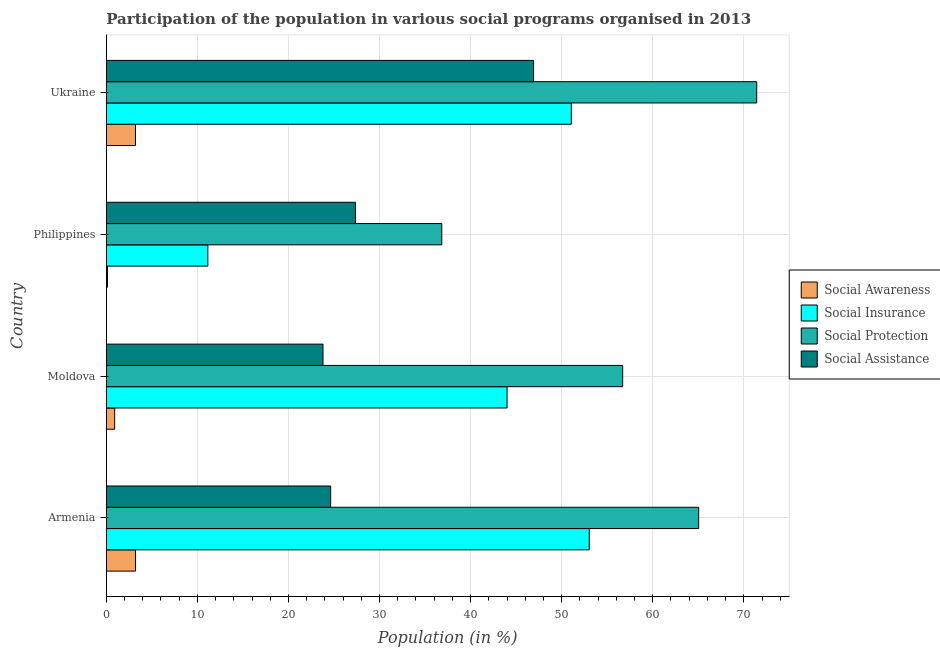How many different coloured bars are there?
Give a very brief answer. 4. Are the number of bars on each tick of the Y-axis equal?
Keep it short and to the point. Yes. How many bars are there on the 2nd tick from the bottom?
Offer a very short reply. 4. What is the label of the 3rd group of bars from the top?
Give a very brief answer. Moldova. In how many cases, is the number of bars for a given country not equal to the number of legend labels?
Your answer should be compact. 0. What is the participation of population in social insurance programs in Ukraine?
Make the answer very short. 51.06. Across all countries, what is the maximum participation of population in social awareness programs?
Make the answer very short. 3.21. Across all countries, what is the minimum participation of population in social assistance programs?
Offer a very short reply. 23.79. In which country was the participation of population in social insurance programs maximum?
Your answer should be compact. Armenia. In which country was the participation of population in social assistance programs minimum?
Ensure brevity in your answer.  Moldova. What is the total participation of population in social assistance programs in the graph?
Your answer should be very brief. 122.7. What is the difference between the participation of population in social insurance programs in Moldova and that in Ukraine?
Your answer should be compact. -7.05. What is the difference between the participation of population in social protection programs in Philippines and the participation of population in social awareness programs in Armenia?
Ensure brevity in your answer.  33.63. What is the average participation of population in social assistance programs per country?
Provide a succinct answer. 30.67. What is the difference between the participation of population in social protection programs and participation of population in social insurance programs in Armenia?
Ensure brevity in your answer.  12.01. In how many countries, is the participation of population in social insurance programs greater than 12 %?
Offer a very short reply. 3. What is the ratio of the participation of population in social protection programs in Moldova to that in Ukraine?
Give a very brief answer. 0.79. Is the participation of population in social assistance programs in Moldova less than that in Philippines?
Make the answer very short. Yes. Is the difference between the participation of population in social insurance programs in Armenia and Philippines greater than the difference between the participation of population in social assistance programs in Armenia and Philippines?
Your answer should be compact. Yes. What is the difference between the highest and the second highest participation of population in social insurance programs?
Your answer should be compact. 1.97. What is the difference between the highest and the lowest participation of population in social insurance programs?
Provide a short and direct response. 41.88. Is the sum of the participation of population in social protection programs in Moldova and Philippines greater than the maximum participation of population in social assistance programs across all countries?
Make the answer very short. Yes. What does the 4th bar from the top in Ukraine represents?
Offer a very short reply. Social Awareness. What does the 2nd bar from the bottom in Ukraine represents?
Keep it short and to the point. Social Insurance. How many bars are there?
Offer a terse response. 16. How many countries are there in the graph?
Your answer should be very brief. 4. What is the difference between two consecutive major ticks on the X-axis?
Provide a succinct answer. 10. Does the graph contain grids?
Ensure brevity in your answer.  Yes. How many legend labels are there?
Give a very brief answer. 4. What is the title of the graph?
Offer a very short reply. Participation of the population in various social programs organised in 2013. What is the label or title of the X-axis?
Make the answer very short. Population (in %). What is the label or title of the Y-axis?
Your response must be concise. Country. What is the Population (in %) in Social Awareness in Armenia?
Provide a short and direct response. 3.21. What is the Population (in %) in Social Insurance in Armenia?
Provide a short and direct response. 53.03. What is the Population (in %) of Social Protection in Armenia?
Provide a short and direct response. 65.04. What is the Population (in %) in Social Assistance in Armenia?
Give a very brief answer. 24.63. What is the Population (in %) in Social Awareness in Moldova?
Provide a succinct answer. 0.92. What is the Population (in %) of Social Insurance in Moldova?
Provide a short and direct response. 44.01. What is the Population (in %) of Social Protection in Moldova?
Your response must be concise. 56.7. What is the Population (in %) of Social Assistance in Moldova?
Your answer should be very brief. 23.79. What is the Population (in %) in Social Awareness in Philippines?
Provide a succinct answer. 0.12. What is the Population (in %) of Social Insurance in Philippines?
Offer a terse response. 11.15. What is the Population (in %) in Social Protection in Philippines?
Your response must be concise. 36.84. What is the Population (in %) in Social Assistance in Philippines?
Give a very brief answer. 27.35. What is the Population (in %) of Social Awareness in Ukraine?
Your answer should be compact. 3.2. What is the Population (in %) of Social Insurance in Ukraine?
Offer a terse response. 51.06. What is the Population (in %) of Social Protection in Ukraine?
Give a very brief answer. 71.42. What is the Population (in %) of Social Assistance in Ukraine?
Provide a short and direct response. 46.92. Across all countries, what is the maximum Population (in %) of Social Awareness?
Your response must be concise. 3.21. Across all countries, what is the maximum Population (in %) of Social Insurance?
Offer a terse response. 53.03. Across all countries, what is the maximum Population (in %) in Social Protection?
Your response must be concise. 71.42. Across all countries, what is the maximum Population (in %) of Social Assistance?
Provide a succinct answer. 46.92. Across all countries, what is the minimum Population (in %) of Social Awareness?
Your answer should be compact. 0.12. Across all countries, what is the minimum Population (in %) of Social Insurance?
Your response must be concise. 11.15. Across all countries, what is the minimum Population (in %) of Social Protection?
Your answer should be compact. 36.84. Across all countries, what is the minimum Population (in %) in Social Assistance?
Your answer should be compact. 23.79. What is the total Population (in %) of Social Awareness in the graph?
Give a very brief answer. 7.45. What is the total Population (in %) of Social Insurance in the graph?
Give a very brief answer. 159.24. What is the total Population (in %) in Social Protection in the graph?
Your response must be concise. 230. What is the total Population (in %) in Social Assistance in the graph?
Offer a very short reply. 122.7. What is the difference between the Population (in %) in Social Awareness in Armenia and that in Moldova?
Ensure brevity in your answer.  2.29. What is the difference between the Population (in %) of Social Insurance in Armenia and that in Moldova?
Make the answer very short. 9.03. What is the difference between the Population (in %) in Social Protection in Armenia and that in Moldova?
Offer a terse response. 8.34. What is the difference between the Population (in %) of Social Assistance in Armenia and that in Moldova?
Offer a very short reply. 0.84. What is the difference between the Population (in %) of Social Awareness in Armenia and that in Philippines?
Make the answer very short. 3.08. What is the difference between the Population (in %) in Social Insurance in Armenia and that in Philippines?
Your answer should be very brief. 41.88. What is the difference between the Population (in %) in Social Protection in Armenia and that in Philippines?
Offer a terse response. 28.21. What is the difference between the Population (in %) in Social Assistance in Armenia and that in Philippines?
Offer a terse response. -2.72. What is the difference between the Population (in %) in Social Awareness in Armenia and that in Ukraine?
Provide a short and direct response. 0. What is the difference between the Population (in %) in Social Insurance in Armenia and that in Ukraine?
Offer a terse response. 1.97. What is the difference between the Population (in %) in Social Protection in Armenia and that in Ukraine?
Provide a short and direct response. -6.38. What is the difference between the Population (in %) of Social Assistance in Armenia and that in Ukraine?
Provide a succinct answer. -22.28. What is the difference between the Population (in %) of Social Awareness in Moldova and that in Philippines?
Your answer should be very brief. 0.79. What is the difference between the Population (in %) in Social Insurance in Moldova and that in Philippines?
Your answer should be compact. 32.86. What is the difference between the Population (in %) in Social Protection in Moldova and that in Philippines?
Your answer should be very brief. 19.86. What is the difference between the Population (in %) in Social Assistance in Moldova and that in Philippines?
Make the answer very short. -3.56. What is the difference between the Population (in %) of Social Awareness in Moldova and that in Ukraine?
Your response must be concise. -2.29. What is the difference between the Population (in %) of Social Insurance in Moldova and that in Ukraine?
Give a very brief answer. -7.05. What is the difference between the Population (in %) in Social Protection in Moldova and that in Ukraine?
Make the answer very short. -14.72. What is the difference between the Population (in %) of Social Assistance in Moldova and that in Ukraine?
Offer a very short reply. -23.13. What is the difference between the Population (in %) in Social Awareness in Philippines and that in Ukraine?
Ensure brevity in your answer.  -3.08. What is the difference between the Population (in %) in Social Insurance in Philippines and that in Ukraine?
Your answer should be compact. -39.91. What is the difference between the Population (in %) of Social Protection in Philippines and that in Ukraine?
Make the answer very short. -34.58. What is the difference between the Population (in %) of Social Assistance in Philippines and that in Ukraine?
Your answer should be compact. -19.56. What is the difference between the Population (in %) in Social Awareness in Armenia and the Population (in %) in Social Insurance in Moldova?
Provide a short and direct response. -40.8. What is the difference between the Population (in %) in Social Awareness in Armenia and the Population (in %) in Social Protection in Moldova?
Your answer should be very brief. -53.49. What is the difference between the Population (in %) of Social Awareness in Armenia and the Population (in %) of Social Assistance in Moldova?
Your response must be concise. -20.59. What is the difference between the Population (in %) in Social Insurance in Armenia and the Population (in %) in Social Protection in Moldova?
Offer a terse response. -3.67. What is the difference between the Population (in %) in Social Insurance in Armenia and the Population (in %) in Social Assistance in Moldova?
Ensure brevity in your answer.  29.24. What is the difference between the Population (in %) of Social Protection in Armenia and the Population (in %) of Social Assistance in Moldova?
Your answer should be compact. 41.25. What is the difference between the Population (in %) of Social Awareness in Armenia and the Population (in %) of Social Insurance in Philippines?
Offer a terse response. -7.94. What is the difference between the Population (in %) of Social Awareness in Armenia and the Population (in %) of Social Protection in Philippines?
Keep it short and to the point. -33.63. What is the difference between the Population (in %) of Social Awareness in Armenia and the Population (in %) of Social Assistance in Philippines?
Offer a terse response. -24.15. What is the difference between the Population (in %) of Social Insurance in Armenia and the Population (in %) of Social Protection in Philippines?
Your answer should be very brief. 16.2. What is the difference between the Population (in %) in Social Insurance in Armenia and the Population (in %) in Social Assistance in Philippines?
Provide a short and direct response. 25.68. What is the difference between the Population (in %) of Social Protection in Armenia and the Population (in %) of Social Assistance in Philippines?
Your response must be concise. 37.69. What is the difference between the Population (in %) of Social Awareness in Armenia and the Population (in %) of Social Insurance in Ukraine?
Provide a short and direct response. -47.85. What is the difference between the Population (in %) of Social Awareness in Armenia and the Population (in %) of Social Protection in Ukraine?
Provide a succinct answer. -68.21. What is the difference between the Population (in %) in Social Awareness in Armenia and the Population (in %) in Social Assistance in Ukraine?
Keep it short and to the point. -43.71. What is the difference between the Population (in %) of Social Insurance in Armenia and the Population (in %) of Social Protection in Ukraine?
Provide a succinct answer. -18.39. What is the difference between the Population (in %) of Social Insurance in Armenia and the Population (in %) of Social Assistance in Ukraine?
Make the answer very short. 6.11. What is the difference between the Population (in %) in Social Protection in Armenia and the Population (in %) in Social Assistance in Ukraine?
Offer a terse response. 18.13. What is the difference between the Population (in %) of Social Awareness in Moldova and the Population (in %) of Social Insurance in Philippines?
Your answer should be compact. -10.23. What is the difference between the Population (in %) in Social Awareness in Moldova and the Population (in %) in Social Protection in Philippines?
Offer a very short reply. -35.92. What is the difference between the Population (in %) of Social Awareness in Moldova and the Population (in %) of Social Assistance in Philippines?
Your answer should be very brief. -26.44. What is the difference between the Population (in %) of Social Insurance in Moldova and the Population (in %) of Social Protection in Philippines?
Provide a short and direct response. 7.17. What is the difference between the Population (in %) in Social Insurance in Moldova and the Population (in %) in Social Assistance in Philippines?
Provide a short and direct response. 16.65. What is the difference between the Population (in %) of Social Protection in Moldova and the Population (in %) of Social Assistance in Philippines?
Offer a very short reply. 29.34. What is the difference between the Population (in %) of Social Awareness in Moldova and the Population (in %) of Social Insurance in Ukraine?
Your response must be concise. -50.14. What is the difference between the Population (in %) in Social Awareness in Moldova and the Population (in %) in Social Protection in Ukraine?
Ensure brevity in your answer.  -70.5. What is the difference between the Population (in %) of Social Awareness in Moldova and the Population (in %) of Social Assistance in Ukraine?
Keep it short and to the point. -46. What is the difference between the Population (in %) of Social Insurance in Moldova and the Population (in %) of Social Protection in Ukraine?
Offer a terse response. -27.41. What is the difference between the Population (in %) in Social Insurance in Moldova and the Population (in %) in Social Assistance in Ukraine?
Provide a succinct answer. -2.91. What is the difference between the Population (in %) in Social Protection in Moldova and the Population (in %) in Social Assistance in Ukraine?
Your answer should be very brief. 9.78. What is the difference between the Population (in %) of Social Awareness in Philippines and the Population (in %) of Social Insurance in Ukraine?
Your answer should be compact. -50.94. What is the difference between the Population (in %) in Social Awareness in Philippines and the Population (in %) in Social Protection in Ukraine?
Make the answer very short. -71.3. What is the difference between the Population (in %) in Social Awareness in Philippines and the Population (in %) in Social Assistance in Ukraine?
Offer a terse response. -46.79. What is the difference between the Population (in %) of Social Insurance in Philippines and the Population (in %) of Social Protection in Ukraine?
Offer a very short reply. -60.27. What is the difference between the Population (in %) in Social Insurance in Philippines and the Population (in %) in Social Assistance in Ukraine?
Provide a succinct answer. -35.77. What is the difference between the Population (in %) of Social Protection in Philippines and the Population (in %) of Social Assistance in Ukraine?
Your response must be concise. -10.08. What is the average Population (in %) in Social Awareness per country?
Your answer should be very brief. 1.86. What is the average Population (in %) of Social Insurance per country?
Make the answer very short. 39.81. What is the average Population (in %) in Social Protection per country?
Your response must be concise. 57.5. What is the average Population (in %) of Social Assistance per country?
Offer a terse response. 30.67. What is the difference between the Population (in %) in Social Awareness and Population (in %) in Social Insurance in Armenia?
Offer a very short reply. -49.83. What is the difference between the Population (in %) in Social Awareness and Population (in %) in Social Protection in Armenia?
Keep it short and to the point. -61.84. What is the difference between the Population (in %) in Social Awareness and Population (in %) in Social Assistance in Armenia?
Give a very brief answer. -21.43. What is the difference between the Population (in %) of Social Insurance and Population (in %) of Social Protection in Armenia?
Offer a terse response. -12.01. What is the difference between the Population (in %) in Social Insurance and Population (in %) in Social Assistance in Armenia?
Keep it short and to the point. 28.4. What is the difference between the Population (in %) in Social Protection and Population (in %) in Social Assistance in Armenia?
Offer a terse response. 40.41. What is the difference between the Population (in %) in Social Awareness and Population (in %) in Social Insurance in Moldova?
Offer a very short reply. -43.09. What is the difference between the Population (in %) in Social Awareness and Population (in %) in Social Protection in Moldova?
Offer a terse response. -55.78. What is the difference between the Population (in %) of Social Awareness and Population (in %) of Social Assistance in Moldova?
Provide a succinct answer. -22.88. What is the difference between the Population (in %) in Social Insurance and Population (in %) in Social Protection in Moldova?
Give a very brief answer. -12.69. What is the difference between the Population (in %) of Social Insurance and Population (in %) of Social Assistance in Moldova?
Offer a terse response. 20.21. What is the difference between the Population (in %) in Social Protection and Population (in %) in Social Assistance in Moldova?
Make the answer very short. 32.91. What is the difference between the Population (in %) in Social Awareness and Population (in %) in Social Insurance in Philippines?
Offer a very short reply. -11.02. What is the difference between the Population (in %) of Social Awareness and Population (in %) of Social Protection in Philippines?
Offer a terse response. -36.71. What is the difference between the Population (in %) in Social Awareness and Population (in %) in Social Assistance in Philippines?
Ensure brevity in your answer.  -27.23. What is the difference between the Population (in %) in Social Insurance and Population (in %) in Social Protection in Philippines?
Ensure brevity in your answer.  -25.69. What is the difference between the Population (in %) of Social Insurance and Population (in %) of Social Assistance in Philippines?
Provide a succinct answer. -16.21. What is the difference between the Population (in %) of Social Protection and Population (in %) of Social Assistance in Philippines?
Your answer should be compact. 9.48. What is the difference between the Population (in %) in Social Awareness and Population (in %) in Social Insurance in Ukraine?
Your answer should be compact. -47.86. What is the difference between the Population (in %) of Social Awareness and Population (in %) of Social Protection in Ukraine?
Your answer should be compact. -68.22. What is the difference between the Population (in %) in Social Awareness and Population (in %) in Social Assistance in Ukraine?
Ensure brevity in your answer.  -43.72. What is the difference between the Population (in %) of Social Insurance and Population (in %) of Social Protection in Ukraine?
Offer a terse response. -20.36. What is the difference between the Population (in %) in Social Insurance and Population (in %) in Social Assistance in Ukraine?
Provide a succinct answer. 4.14. What is the difference between the Population (in %) in Social Protection and Population (in %) in Social Assistance in Ukraine?
Provide a short and direct response. 24.5. What is the ratio of the Population (in %) in Social Awareness in Armenia to that in Moldova?
Ensure brevity in your answer.  3.5. What is the ratio of the Population (in %) in Social Insurance in Armenia to that in Moldova?
Your answer should be compact. 1.21. What is the ratio of the Population (in %) of Social Protection in Armenia to that in Moldova?
Your answer should be compact. 1.15. What is the ratio of the Population (in %) of Social Assistance in Armenia to that in Moldova?
Offer a very short reply. 1.04. What is the ratio of the Population (in %) of Social Awareness in Armenia to that in Philippines?
Keep it short and to the point. 26.09. What is the ratio of the Population (in %) in Social Insurance in Armenia to that in Philippines?
Provide a short and direct response. 4.76. What is the ratio of the Population (in %) in Social Protection in Armenia to that in Philippines?
Provide a succinct answer. 1.77. What is the ratio of the Population (in %) of Social Assistance in Armenia to that in Philippines?
Give a very brief answer. 0.9. What is the ratio of the Population (in %) of Social Awareness in Armenia to that in Ukraine?
Ensure brevity in your answer.  1. What is the ratio of the Population (in %) of Social Insurance in Armenia to that in Ukraine?
Provide a succinct answer. 1.04. What is the ratio of the Population (in %) in Social Protection in Armenia to that in Ukraine?
Ensure brevity in your answer.  0.91. What is the ratio of the Population (in %) in Social Assistance in Armenia to that in Ukraine?
Provide a short and direct response. 0.53. What is the ratio of the Population (in %) of Social Awareness in Moldova to that in Philippines?
Offer a very short reply. 7.45. What is the ratio of the Population (in %) in Social Insurance in Moldova to that in Philippines?
Offer a terse response. 3.95. What is the ratio of the Population (in %) in Social Protection in Moldova to that in Philippines?
Your answer should be compact. 1.54. What is the ratio of the Population (in %) of Social Assistance in Moldova to that in Philippines?
Your answer should be compact. 0.87. What is the ratio of the Population (in %) of Social Awareness in Moldova to that in Ukraine?
Keep it short and to the point. 0.29. What is the ratio of the Population (in %) in Social Insurance in Moldova to that in Ukraine?
Offer a terse response. 0.86. What is the ratio of the Population (in %) in Social Protection in Moldova to that in Ukraine?
Your answer should be very brief. 0.79. What is the ratio of the Population (in %) in Social Assistance in Moldova to that in Ukraine?
Keep it short and to the point. 0.51. What is the ratio of the Population (in %) in Social Awareness in Philippines to that in Ukraine?
Keep it short and to the point. 0.04. What is the ratio of the Population (in %) of Social Insurance in Philippines to that in Ukraine?
Give a very brief answer. 0.22. What is the ratio of the Population (in %) of Social Protection in Philippines to that in Ukraine?
Offer a terse response. 0.52. What is the ratio of the Population (in %) of Social Assistance in Philippines to that in Ukraine?
Your answer should be very brief. 0.58. What is the difference between the highest and the second highest Population (in %) in Social Awareness?
Keep it short and to the point. 0. What is the difference between the highest and the second highest Population (in %) in Social Insurance?
Keep it short and to the point. 1.97. What is the difference between the highest and the second highest Population (in %) of Social Protection?
Ensure brevity in your answer.  6.38. What is the difference between the highest and the second highest Population (in %) in Social Assistance?
Give a very brief answer. 19.56. What is the difference between the highest and the lowest Population (in %) of Social Awareness?
Your answer should be very brief. 3.08. What is the difference between the highest and the lowest Population (in %) of Social Insurance?
Give a very brief answer. 41.88. What is the difference between the highest and the lowest Population (in %) in Social Protection?
Provide a short and direct response. 34.58. What is the difference between the highest and the lowest Population (in %) in Social Assistance?
Give a very brief answer. 23.13. 